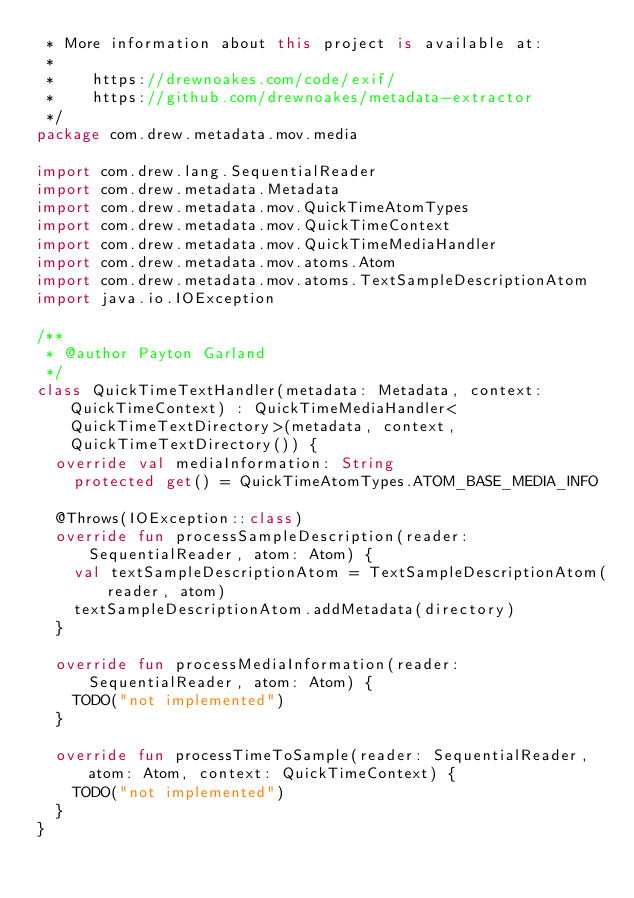<code> <loc_0><loc_0><loc_500><loc_500><_Kotlin_> * More information about this project is available at:
 *
 *    https://drewnoakes.com/code/exif/
 *    https://github.com/drewnoakes/metadata-extractor
 */
package com.drew.metadata.mov.media

import com.drew.lang.SequentialReader
import com.drew.metadata.Metadata
import com.drew.metadata.mov.QuickTimeAtomTypes
import com.drew.metadata.mov.QuickTimeContext
import com.drew.metadata.mov.QuickTimeMediaHandler
import com.drew.metadata.mov.atoms.Atom
import com.drew.metadata.mov.atoms.TextSampleDescriptionAtom
import java.io.IOException

/**
 * @author Payton Garland
 */
class QuickTimeTextHandler(metadata: Metadata, context: QuickTimeContext) : QuickTimeMediaHandler<QuickTimeTextDirectory>(metadata, context, QuickTimeTextDirectory()) {
  override val mediaInformation: String
    protected get() = QuickTimeAtomTypes.ATOM_BASE_MEDIA_INFO

  @Throws(IOException::class)
  override fun processSampleDescription(reader: SequentialReader, atom: Atom) {
    val textSampleDescriptionAtom = TextSampleDescriptionAtom(reader, atom)
    textSampleDescriptionAtom.addMetadata(directory)
  }

  override fun processMediaInformation(reader: SequentialReader, atom: Atom) {
    TODO("not implemented")
  }

  override fun processTimeToSample(reader: SequentialReader, atom: Atom, context: QuickTimeContext) {
    TODO("not implemented")
  }
}
</code> 